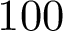Convert formula to latex. <formula><loc_0><loc_0><loc_500><loc_500>1 0 0</formula> 